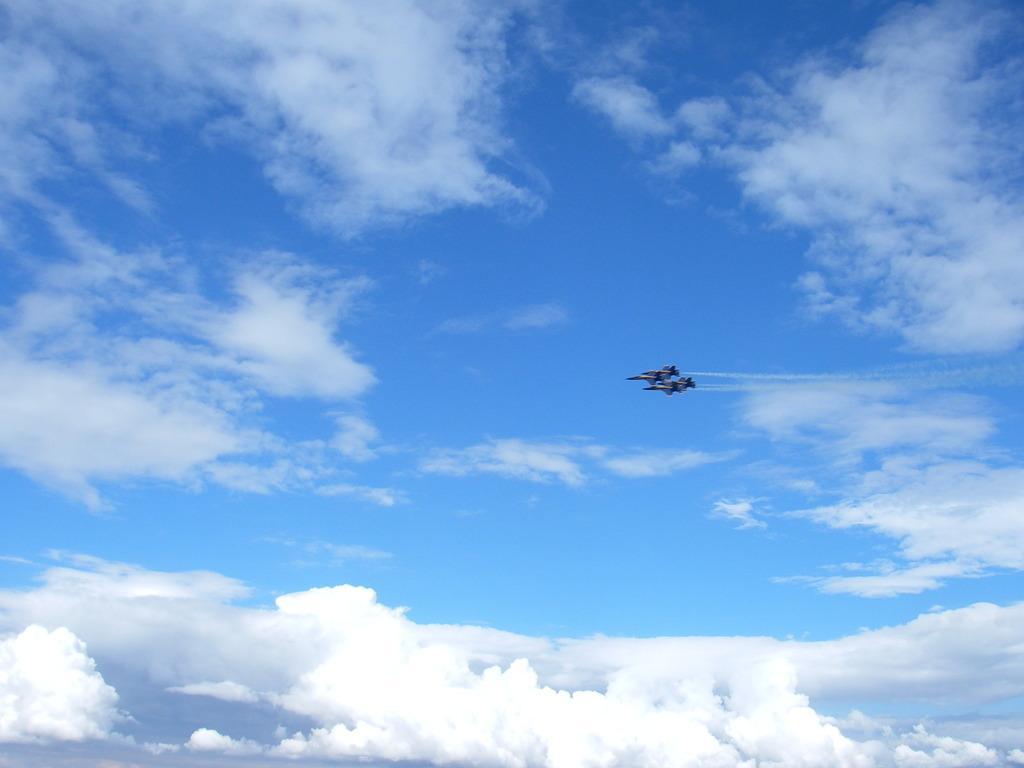Please provide a concise description of this image. Here we can see two planes flying in the sky and we there are clouds in the sky. 